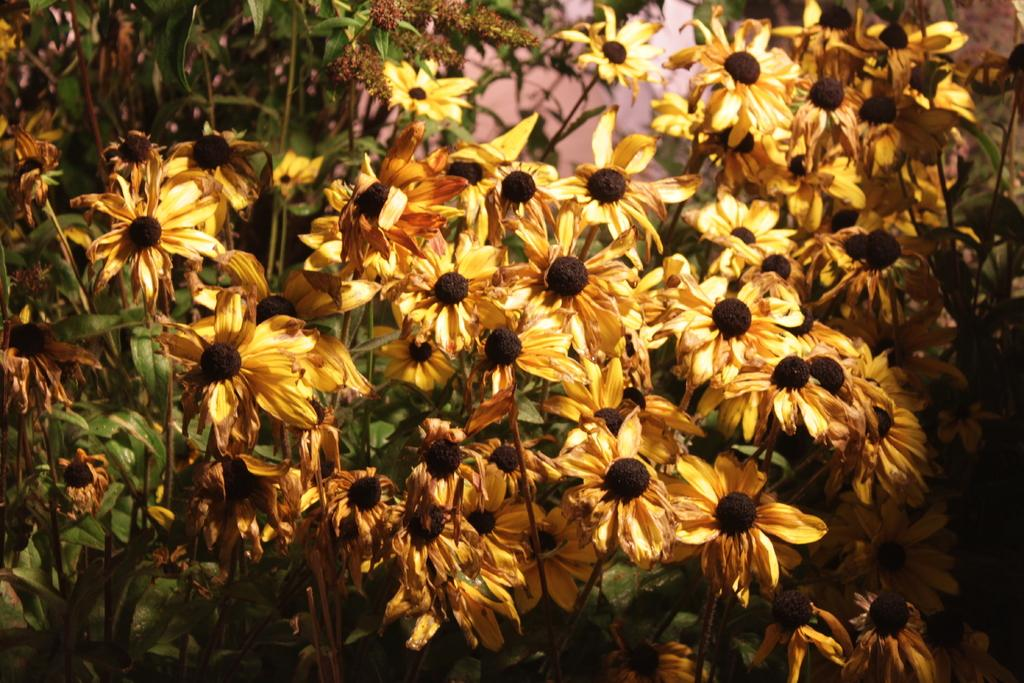What type of plants can be seen in the image? There are flowers and trees in the image. Can you describe the vegetation in more detail? The image features flowers and trees, which are both types of plants. What type of fruit can be seen hanging from the trees in the image? There is no fruit visible in the image; only flowers and trees are present. What design elements can be seen in the image? The image does not show any specific design elements, as it primarily features natural elements like flowers and trees. 